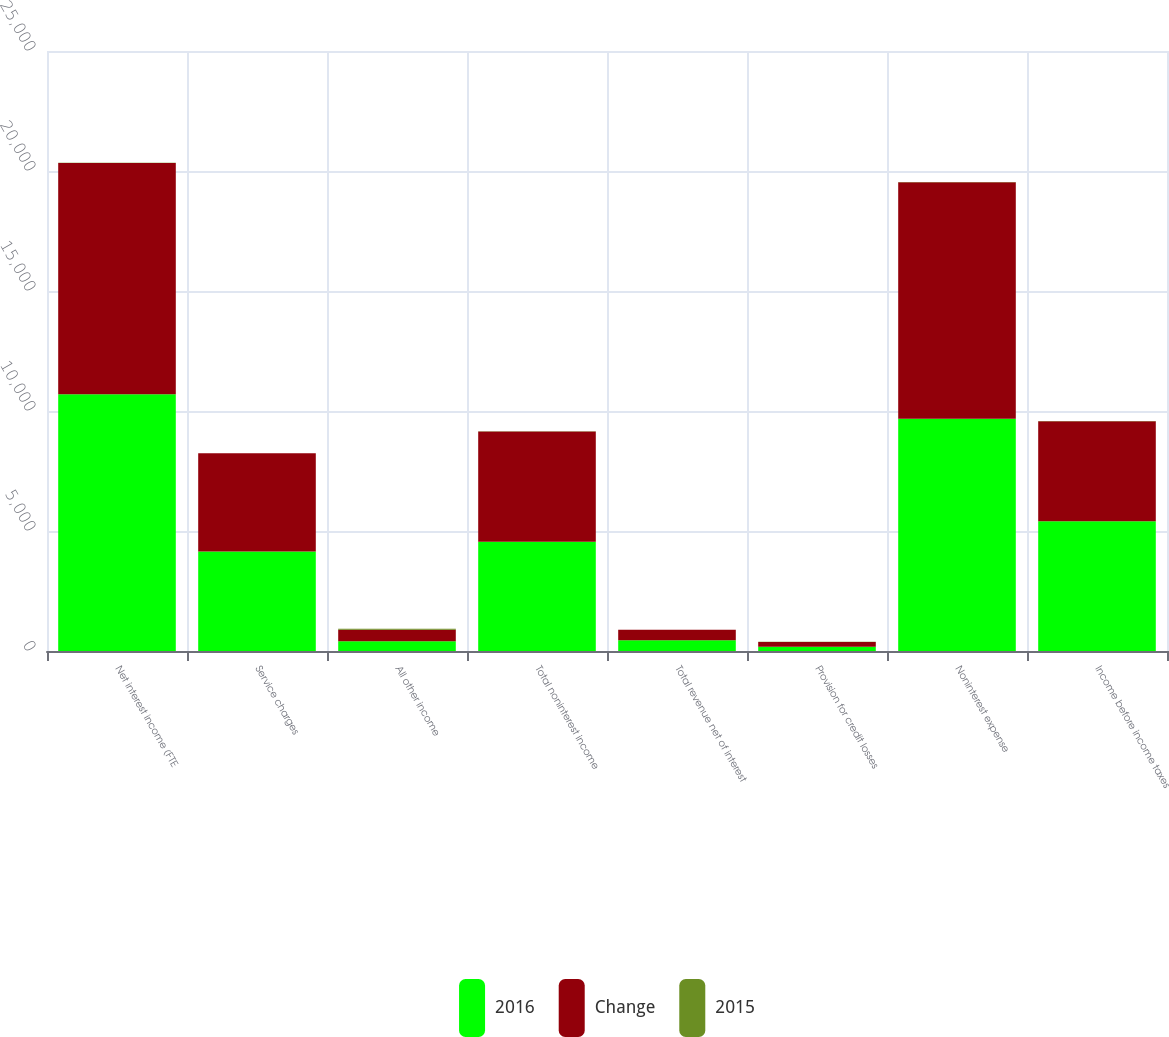Convert chart to OTSL. <chart><loc_0><loc_0><loc_500><loc_500><stacked_bar_chart><ecel><fcel>Net interest income (FTE<fcel>Service charges<fcel>All other income<fcel>Total noninterest income<fcel>Total revenue net of interest<fcel>Provision for credit losses<fcel>Noninterest expense<fcel>Income before income taxes<nl><fcel>2016<fcel>10701<fcel>4141<fcel>403<fcel>4553<fcel>443<fcel>174<fcel>9678<fcel>5402<nl><fcel>Change<fcel>9635<fcel>4100<fcel>483<fcel>4594<fcel>443<fcel>200<fcel>9856<fcel>4173<nl><fcel>2015<fcel>4<fcel>1<fcel>44<fcel>6<fcel>1<fcel>16<fcel>6<fcel>9<nl></chart> 